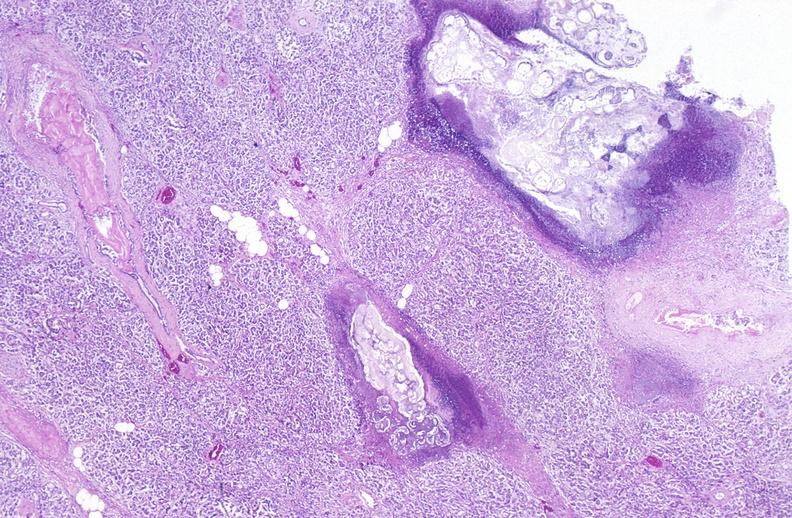does subdiaphragmatic abscess show pancreatic fat necrosis?
Answer the question using a single word or phrase. No 